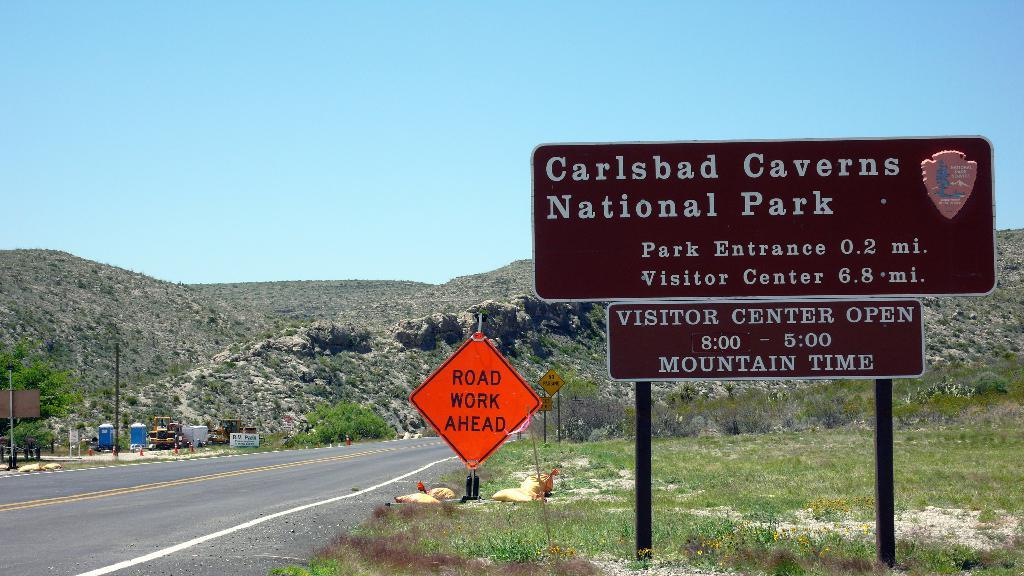<image>
Summarize the visual content of the image. Highway sign which says Carlsbad Caverns National Park on it. 